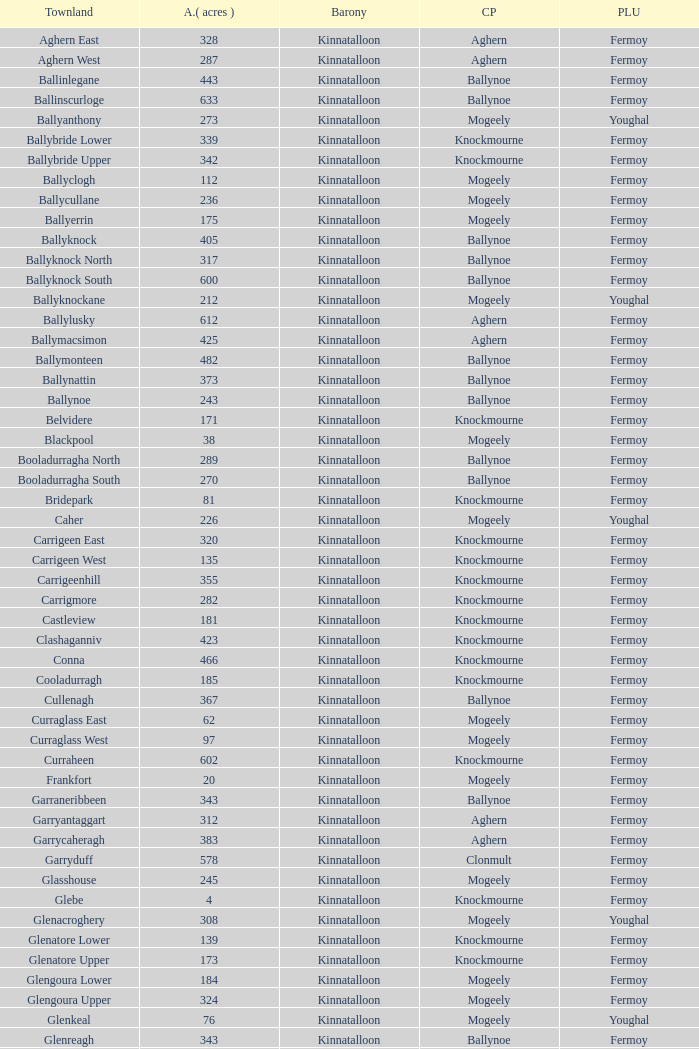Name the civil parish for garryduff Clonmult. 